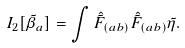<formula> <loc_0><loc_0><loc_500><loc_500>I _ { 2 } [ \tilde { \beta } _ { a } ] = \int \hat { \tilde { F } } _ { ( a b ) } \hat { \tilde { F } } _ { ( a b ) } \tilde { \eta } .</formula> 